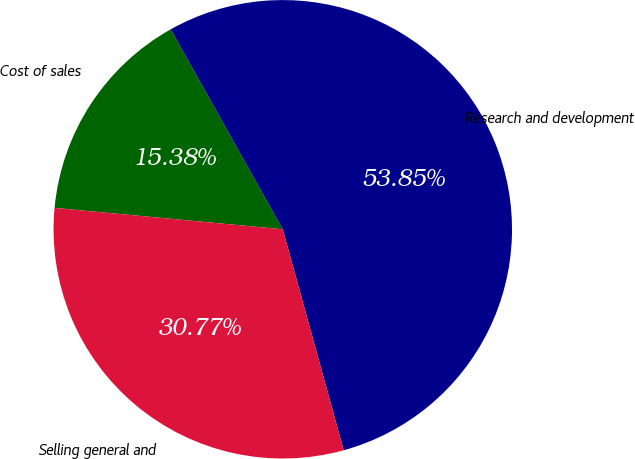Convert chart to OTSL. <chart><loc_0><loc_0><loc_500><loc_500><pie_chart><fcel>Cost of sales<fcel>Research and development<fcel>Selling general and<nl><fcel>15.38%<fcel>53.85%<fcel>30.77%<nl></chart> 